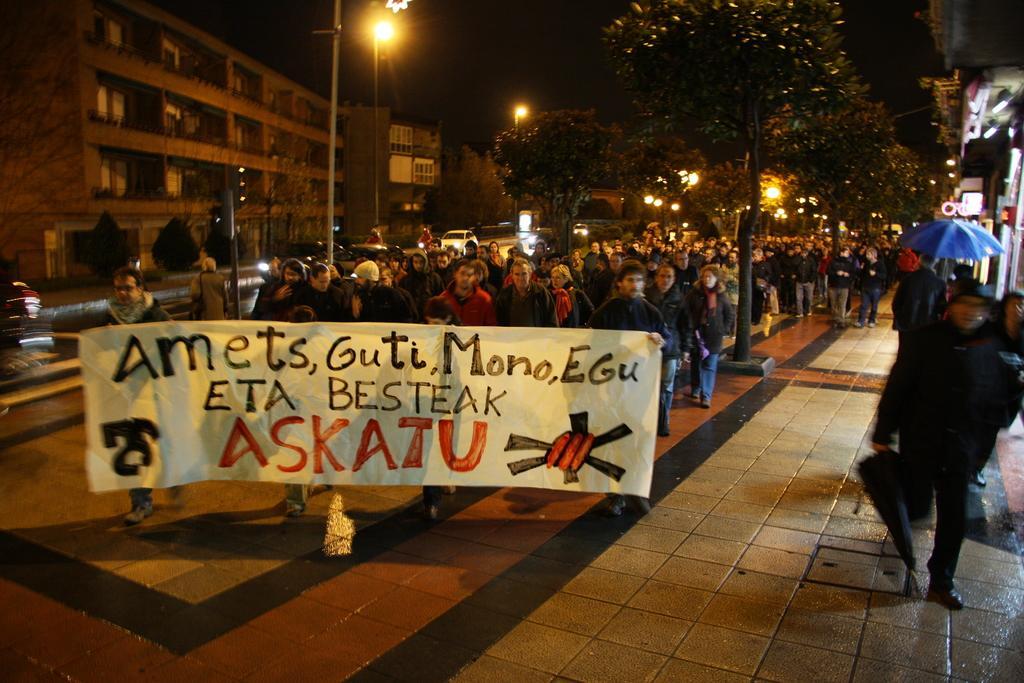Describe this image in one or two sentences. In this picture there are people in the center of the image, by holding posters in there hands and there are buildings and trees in the background area of the image, there are poles in the image and there are shops on the right side of the image, it seems to be a march. 